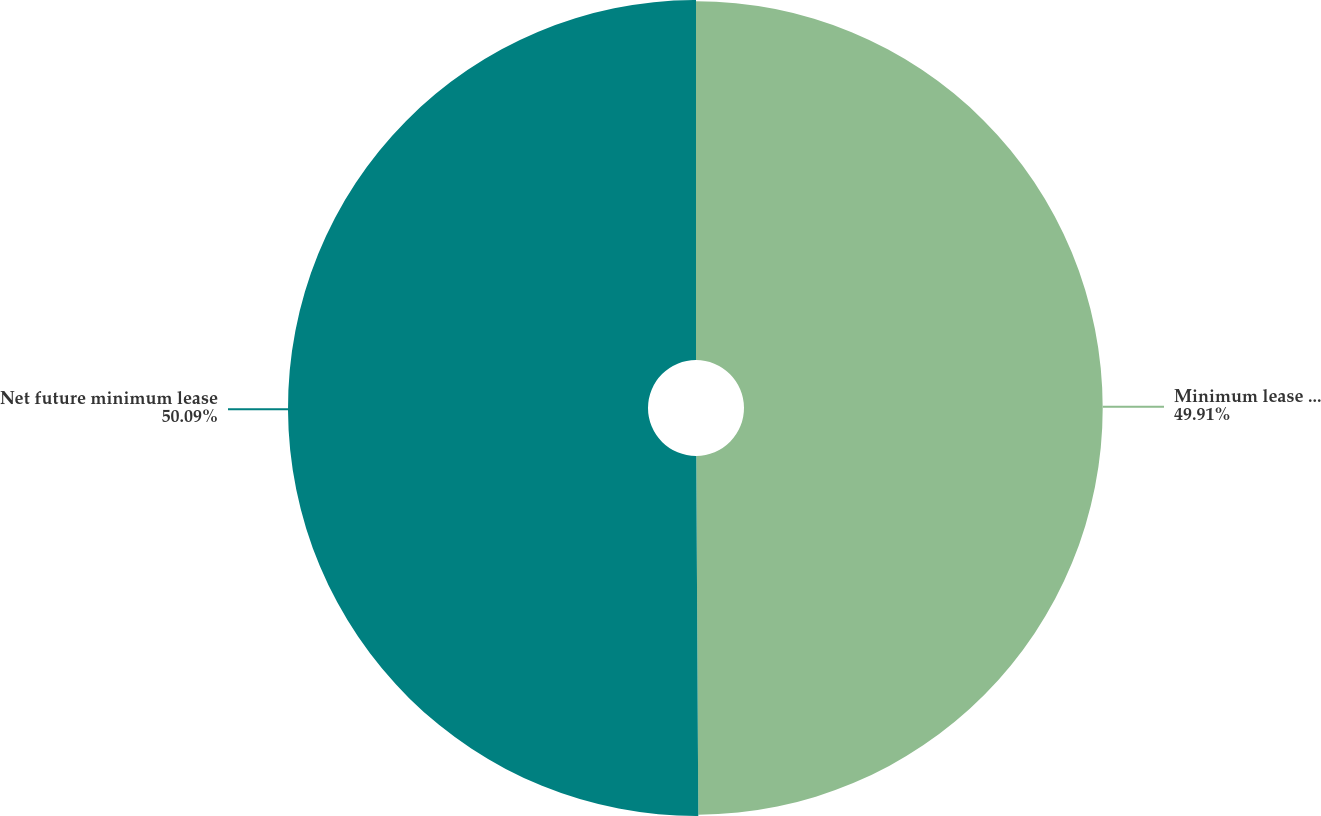Convert chart. <chart><loc_0><loc_0><loc_500><loc_500><pie_chart><fcel>Minimum lease payments<fcel>Net future minimum lease<nl><fcel>49.91%<fcel>50.09%<nl></chart> 